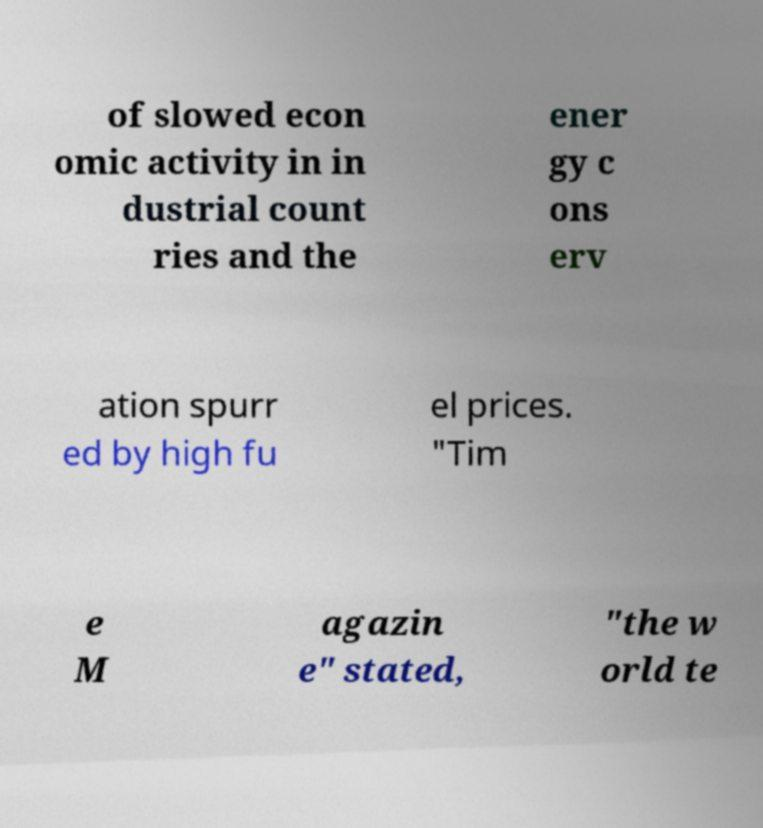Please identify and transcribe the text found in this image. of slowed econ omic activity in in dustrial count ries and the ener gy c ons erv ation spurr ed by high fu el prices. "Tim e M agazin e" stated, "the w orld te 